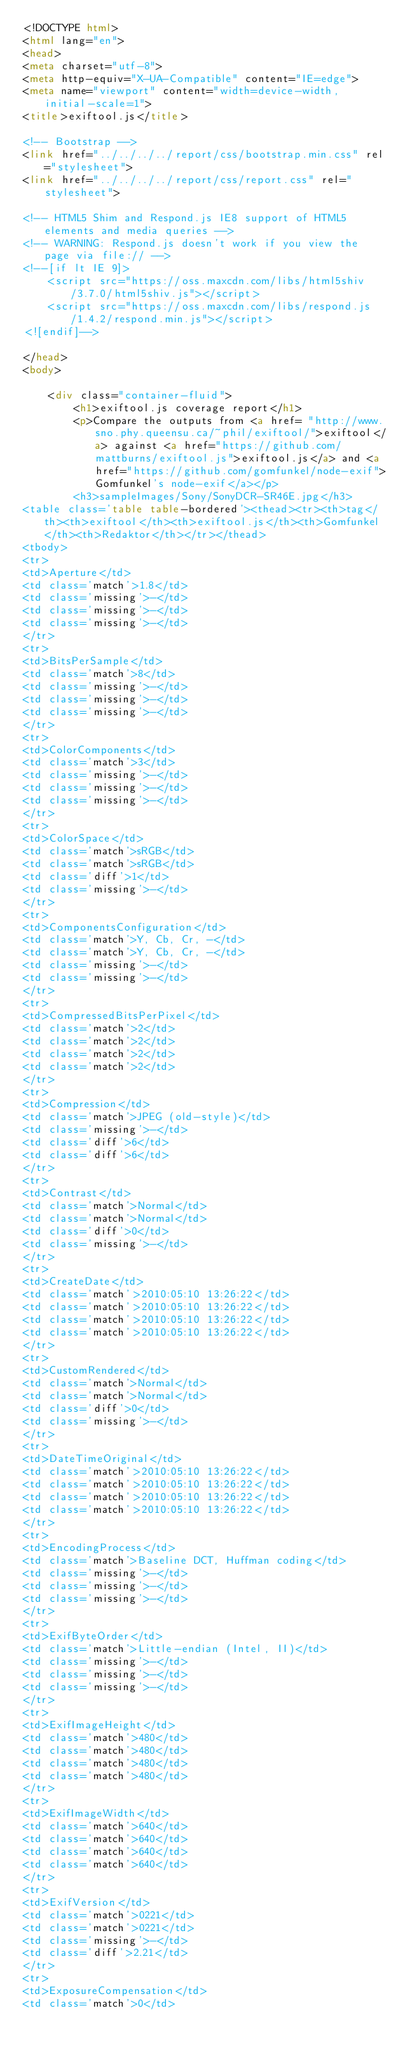<code> <loc_0><loc_0><loc_500><loc_500><_HTML_><!DOCTYPE html>
<html lang="en">
<head>
<meta charset="utf-8">
<meta http-equiv="X-UA-Compatible" content="IE=edge">
<meta name="viewport" content="width=device-width, initial-scale=1">
<title>exiftool.js</title>

<!-- Bootstrap -->
<link href="../../../../report/css/bootstrap.min.css" rel="stylesheet">
<link href="../../../../report/css/report.css" rel="stylesheet">

<!-- HTML5 Shim and Respond.js IE8 support of HTML5 elements and media queries -->
<!-- WARNING: Respond.js doesn't work if you view the page via file:// -->
<!--[if lt IE 9]>
    <script src="https://oss.maxcdn.com/libs/html5shiv/3.7.0/html5shiv.js"></script>
    <script src="https://oss.maxcdn.com/libs/respond.js/1.4.2/respond.min.js"></script>
<![endif]-->

</head>
<body>

    <div class="container-fluid">
        <h1>exiftool.js coverage report</h1>
        <p>Compare the outputs from <a href= "http://www.sno.phy.queensu.ca/~phil/exiftool/">exiftool</a> against <a href="https://github.com/mattburns/exiftool.js">exiftool.js</a> and <a href="https://github.com/gomfunkel/node-exif">Gomfunkel's node-exif</a></p>
        <h3>sampleImages/Sony/SonyDCR-SR46E.jpg</h3>
<table class='table table-bordered'><thead><tr><th>tag</th><th>exiftool</th><th>exiftool.js</th><th>Gomfunkel</th><th>Redaktor</th></tr></thead>
<tbody>
<tr>
<td>Aperture</td>
<td class='match'>1.8</td>
<td class='missing'>-</td>
<td class='missing'>-</td>
<td class='missing'>-</td>
</tr>
<tr>
<td>BitsPerSample</td>
<td class='match'>8</td>
<td class='missing'>-</td>
<td class='missing'>-</td>
<td class='missing'>-</td>
</tr>
<tr>
<td>ColorComponents</td>
<td class='match'>3</td>
<td class='missing'>-</td>
<td class='missing'>-</td>
<td class='missing'>-</td>
</tr>
<tr>
<td>ColorSpace</td>
<td class='match'>sRGB</td>
<td class='match'>sRGB</td>
<td class='diff'>1</td>
<td class='missing'>-</td>
</tr>
<tr>
<td>ComponentsConfiguration</td>
<td class='match'>Y, Cb, Cr, -</td>
<td class='match'>Y, Cb, Cr, -</td>
<td class='missing'>-</td>
<td class='missing'>-</td>
</tr>
<tr>
<td>CompressedBitsPerPixel</td>
<td class='match'>2</td>
<td class='match'>2</td>
<td class='match'>2</td>
<td class='match'>2</td>
</tr>
<tr>
<td>Compression</td>
<td class='match'>JPEG (old-style)</td>
<td class='missing'>-</td>
<td class='diff'>6</td>
<td class='diff'>6</td>
</tr>
<tr>
<td>Contrast</td>
<td class='match'>Normal</td>
<td class='match'>Normal</td>
<td class='diff'>0</td>
<td class='missing'>-</td>
</tr>
<tr>
<td>CreateDate</td>
<td class='match'>2010:05:10 13:26:22</td>
<td class='match'>2010:05:10 13:26:22</td>
<td class='match'>2010:05:10 13:26:22</td>
<td class='match'>2010:05:10 13:26:22</td>
</tr>
<tr>
<td>CustomRendered</td>
<td class='match'>Normal</td>
<td class='match'>Normal</td>
<td class='diff'>0</td>
<td class='missing'>-</td>
</tr>
<tr>
<td>DateTimeOriginal</td>
<td class='match'>2010:05:10 13:26:22</td>
<td class='match'>2010:05:10 13:26:22</td>
<td class='match'>2010:05:10 13:26:22</td>
<td class='match'>2010:05:10 13:26:22</td>
</tr>
<tr>
<td>EncodingProcess</td>
<td class='match'>Baseline DCT, Huffman coding</td>
<td class='missing'>-</td>
<td class='missing'>-</td>
<td class='missing'>-</td>
</tr>
<tr>
<td>ExifByteOrder</td>
<td class='match'>Little-endian (Intel, II)</td>
<td class='missing'>-</td>
<td class='missing'>-</td>
<td class='missing'>-</td>
</tr>
<tr>
<td>ExifImageHeight</td>
<td class='match'>480</td>
<td class='match'>480</td>
<td class='match'>480</td>
<td class='match'>480</td>
</tr>
<tr>
<td>ExifImageWidth</td>
<td class='match'>640</td>
<td class='match'>640</td>
<td class='match'>640</td>
<td class='match'>640</td>
</tr>
<tr>
<td>ExifVersion</td>
<td class='match'>0221</td>
<td class='match'>0221</td>
<td class='missing'>-</td>
<td class='diff'>2.21</td>
</tr>
<tr>
<td>ExposureCompensation</td>
<td class='match'>0</td></code> 